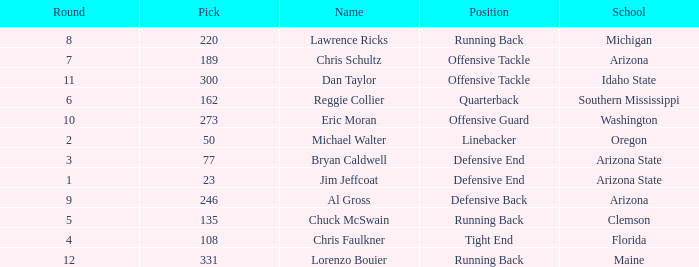What is the largest pick in round 8? 220.0. 